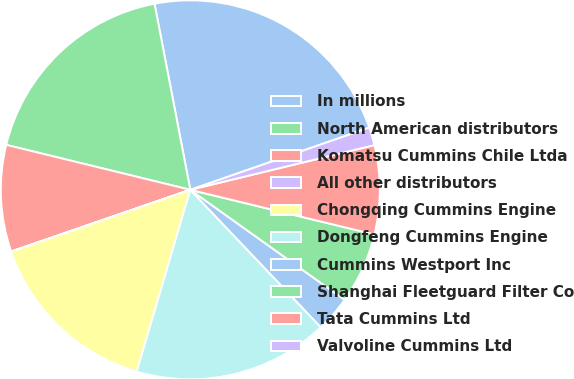Convert chart. <chart><loc_0><loc_0><loc_500><loc_500><pie_chart><fcel>In millions<fcel>North American distributors<fcel>Komatsu Cummins Chile Ltda<fcel>All other distributors<fcel>Chongqing Cummins Engine<fcel>Dongfeng Cummins Engine<fcel>Cummins Westport Inc<fcel>Shanghai Fleetguard Filter Co<fcel>Tata Cummins Ltd<fcel>Valvoline Cummins Ltd<nl><fcel>22.7%<fcel>18.16%<fcel>9.09%<fcel>0.02%<fcel>15.14%<fcel>16.65%<fcel>3.05%<fcel>6.07%<fcel>7.58%<fcel>1.53%<nl></chart> 